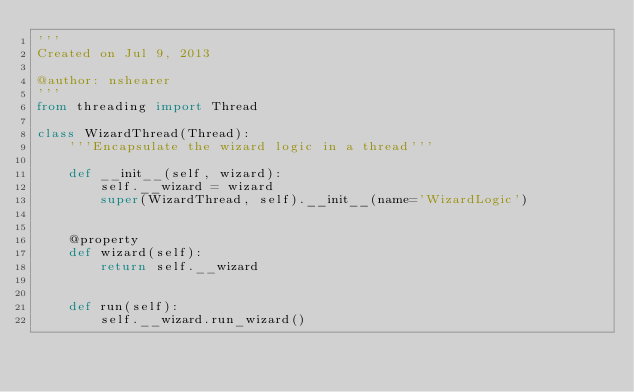Convert code to text. <code><loc_0><loc_0><loc_500><loc_500><_Python_>'''
Created on Jul 9, 2013

@author: nshearer
'''
from threading import Thread

class WizardThread(Thread):
    '''Encapsulate the wizard logic in a thread'''
    
    def __init__(self, wizard):
        self.__wizard = wizard
        super(WizardThread, self).__init__(name='WizardLogic')
        
        
    @property
    def wizard(self):
        return self.__wizard
    
    
    def run(self):
        self.__wizard.run_wizard()</code> 